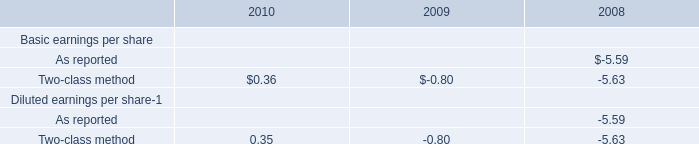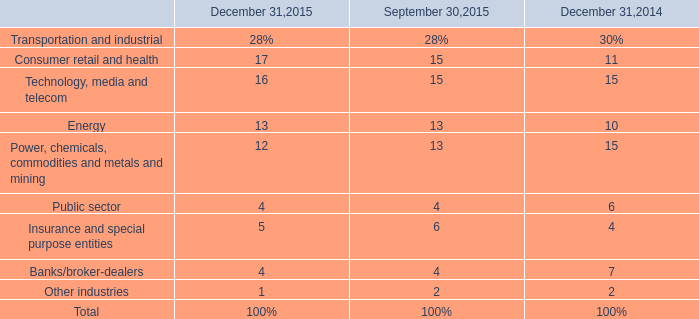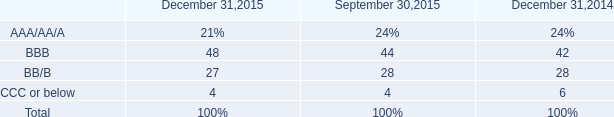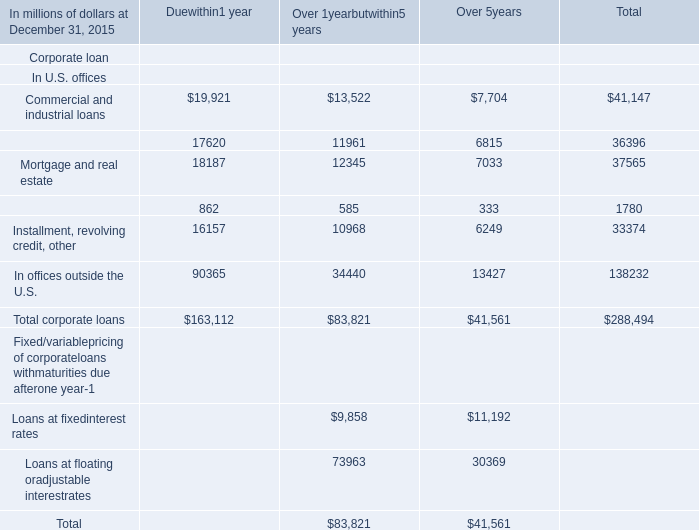Which year is the rate for Technology, media and telecom on December 31 greater than 15% ? 
Answer: 2015. 